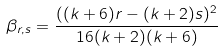Convert formula to latex. <formula><loc_0><loc_0><loc_500><loc_500>\beta _ { r , s } = \frac { ( ( k + 6 ) r - ( k + 2 ) s ) ^ { 2 } } { 1 6 ( k + 2 ) ( k + 6 ) }</formula> 